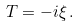Convert formula to latex. <formula><loc_0><loc_0><loc_500><loc_500>T = - i \xi \, .</formula> 